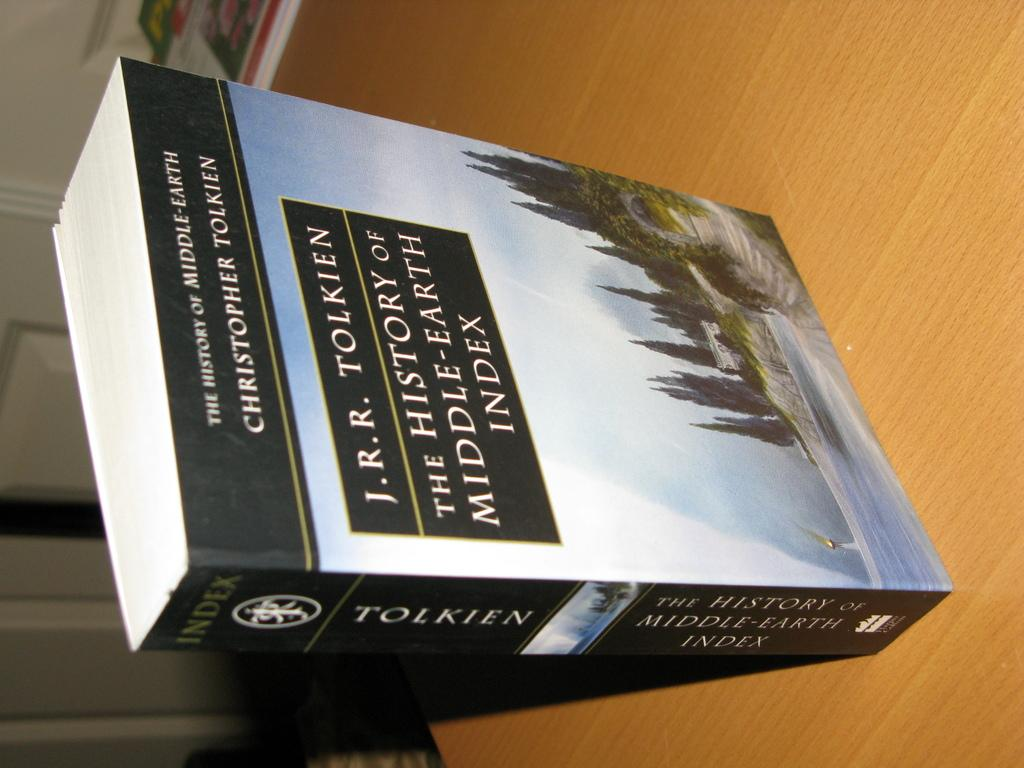<image>
Write a terse but informative summary of the picture. A J.R.R. Tolkien reference book is titled The History of Middle-Earth Index. 